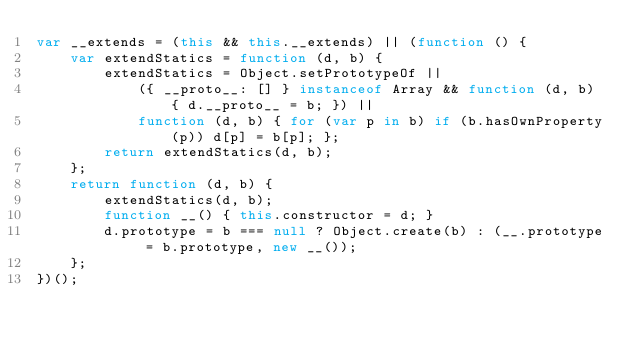Convert code to text. <code><loc_0><loc_0><loc_500><loc_500><_JavaScript_>var __extends = (this && this.__extends) || (function () {
    var extendStatics = function (d, b) {
        extendStatics = Object.setPrototypeOf ||
            ({ __proto__: [] } instanceof Array && function (d, b) { d.__proto__ = b; }) ||
            function (d, b) { for (var p in b) if (b.hasOwnProperty(p)) d[p] = b[p]; };
        return extendStatics(d, b);
    };
    return function (d, b) {
        extendStatics(d, b);
        function __() { this.constructor = d; }
        d.prototype = b === null ? Object.create(b) : (__.prototype = b.prototype, new __());
    };
})();</code> 